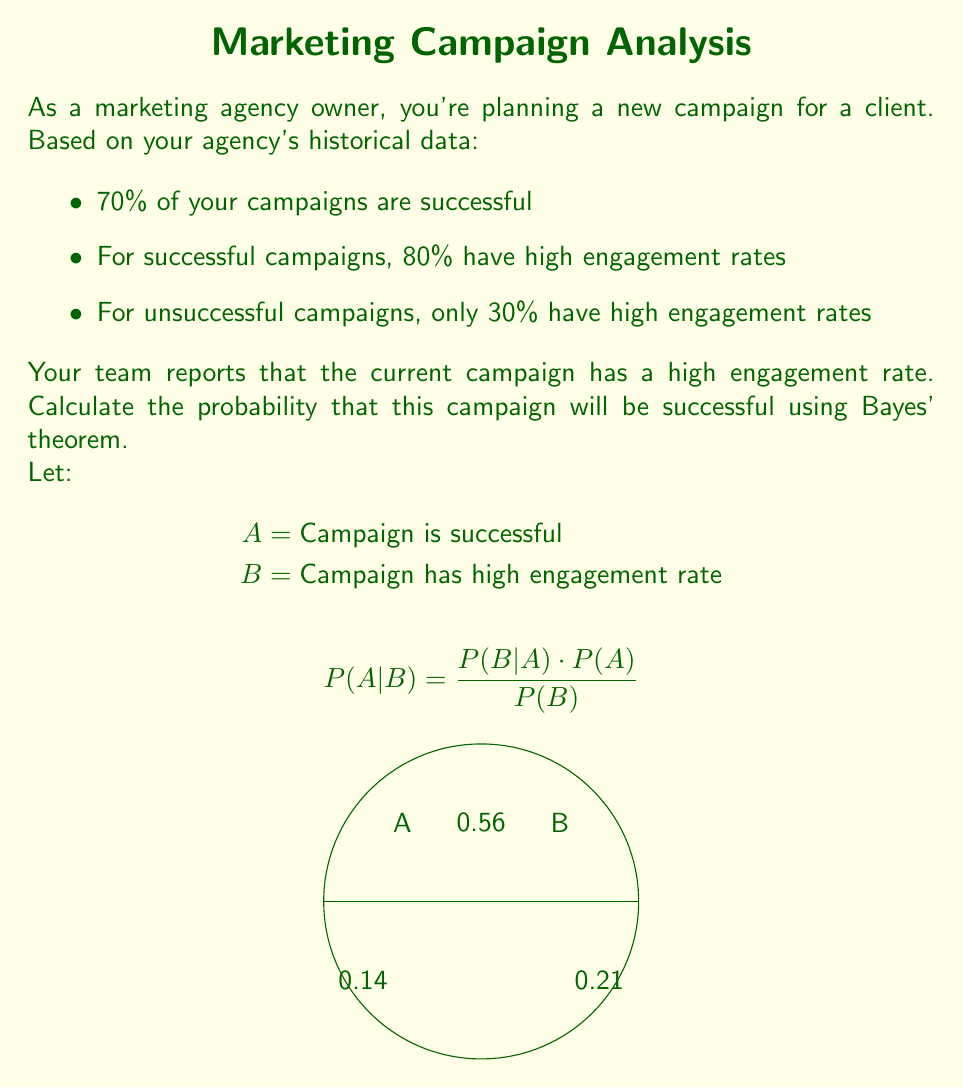Provide a solution to this math problem. Let's approach this step-by-step using Bayes' theorem:

1) First, let's identify the given probabilities:
   $P(A) = 0.70$ (prior probability of success)
   $P(B|A) = 0.80$ (likelihood of high engagement given success)
   $P(B|\text{not }A) = 0.30$ (likelihood of high engagement given failure)

2) We need to calculate $P(B)$ using the law of total probability:
   $P(B) = P(B|A) \cdot P(A) + P(B|\text{not }A) \cdot P(\text{not }A)$
   $P(B) = 0.80 \cdot 0.70 + 0.30 \cdot (1 - 0.70)$
   $P(B) = 0.56 + 0.09 = 0.65$

3) Now we can apply Bayes' theorem:
   $$P(A|B) = \frac{P(B|A) \cdot P(A)}{P(B)}$$
   
   $$P(A|B) = \frac{0.80 \cdot 0.70}{0.65}$$

4) Calculate the final probability:
   $$P(A|B) = \frac{0.56}{0.65} \approx 0.8615$$

Therefore, given that the current campaign has a high engagement rate, the probability that it will be successful is approximately 0.8615 or 86.15%.
Answer: $P(A|B) \approx 0.8615$ or $86.15\%$ 